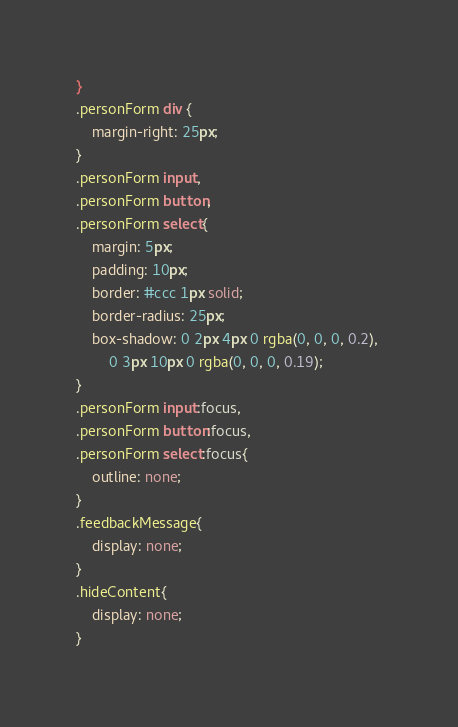<code> <loc_0><loc_0><loc_500><loc_500><_CSS_>}
.personForm div {
    margin-right: 25px;
}
.personForm input, 
.personForm button, 
.personForm select{
    margin: 5px;
    padding: 10px;
    border: #ccc 1px solid;
    border-radius: 25px;
    box-shadow: 0 2px 4px 0 rgba(0, 0, 0, 0.2), 
        0 3px 10px 0 rgba(0, 0, 0, 0.19);
}
.personForm input:focus, 
.personForm button:focus, 
.personForm select:focus{
    outline: none;
}
.feedbackMessage{
    display: none;
}
.hideContent{
    display: none;
}</code> 